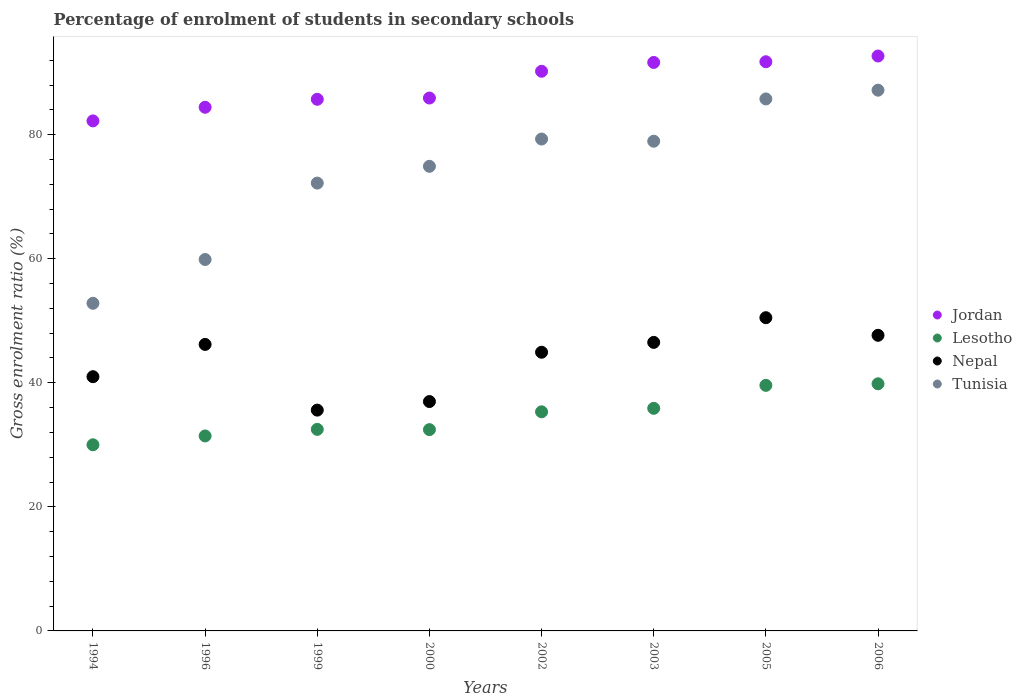Is the number of dotlines equal to the number of legend labels?
Provide a succinct answer. Yes. What is the percentage of students enrolled in secondary schools in Jordan in 2000?
Provide a short and direct response. 85.91. Across all years, what is the maximum percentage of students enrolled in secondary schools in Tunisia?
Your response must be concise. 87.17. Across all years, what is the minimum percentage of students enrolled in secondary schools in Tunisia?
Offer a very short reply. 52.82. In which year was the percentage of students enrolled in secondary schools in Jordan minimum?
Your answer should be very brief. 1994. What is the total percentage of students enrolled in secondary schools in Lesotho in the graph?
Offer a very short reply. 277.01. What is the difference between the percentage of students enrolled in secondary schools in Nepal in 1994 and that in 2000?
Make the answer very short. 4.01. What is the difference between the percentage of students enrolled in secondary schools in Nepal in 2006 and the percentage of students enrolled in secondary schools in Jordan in 1999?
Give a very brief answer. -38.04. What is the average percentage of students enrolled in secondary schools in Jordan per year?
Give a very brief answer. 88.07. In the year 2002, what is the difference between the percentage of students enrolled in secondary schools in Jordan and percentage of students enrolled in secondary schools in Tunisia?
Give a very brief answer. 10.92. What is the ratio of the percentage of students enrolled in secondary schools in Nepal in 2005 to that in 2006?
Make the answer very short. 1.06. Is the percentage of students enrolled in secondary schools in Lesotho in 1996 less than that in 2003?
Ensure brevity in your answer.  Yes. Is the difference between the percentage of students enrolled in secondary schools in Jordan in 1996 and 1999 greater than the difference between the percentage of students enrolled in secondary schools in Tunisia in 1996 and 1999?
Give a very brief answer. Yes. What is the difference between the highest and the second highest percentage of students enrolled in secondary schools in Jordan?
Offer a very short reply. 0.93. What is the difference between the highest and the lowest percentage of students enrolled in secondary schools in Lesotho?
Offer a very short reply. 9.83. Is it the case that in every year, the sum of the percentage of students enrolled in secondary schools in Jordan and percentage of students enrolled in secondary schools in Lesotho  is greater than the percentage of students enrolled in secondary schools in Tunisia?
Keep it short and to the point. Yes. Does the percentage of students enrolled in secondary schools in Jordan monotonically increase over the years?
Offer a terse response. Yes. Is the percentage of students enrolled in secondary schools in Lesotho strictly less than the percentage of students enrolled in secondary schools in Jordan over the years?
Your answer should be very brief. Yes. How many years are there in the graph?
Your answer should be compact. 8. What is the difference between two consecutive major ticks on the Y-axis?
Provide a short and direct response. 20. How many legend labels are there?
Offer a terse response. 4. How are the legend labels stacked?
Make the answer very short. Vertical. What is the title of the graph?
Your answer should be compact. Percentage of enrolment of students in secondary schools. Does "Algeria" appear as one of the legend labels in the graph?
Keep it short and to the point. No. What is the Gross enrolment ratio (%) of Jordan in 1994?
Offer a terse response. 82.22. What is the Gross enrolment ratio (%) of Lesotho in 1994?
Ensure brevity in your answer.  30.01. What is the Gross enrolment ratio (%) of Nepal in 1994?
Keep it short and to the point. 40.98. What is the Gross enrolment ratio (%) in Tunisia in 1994?
Offer a terse response. 52.82. What is the Gross enrolment ratio (%) of Jordan in 1996?
Make the answer very short. 84.42. What is the Gross enrolment ratio (%) of Lesotho in 1996?
Offer a terse response. 31.43. What is the Gross enrolment ratio (%) in Nepal in 1996?
Your answer should be very brief. 46.19. What is the Gross enrolment ratio (%) of Tunisia in 1996?
Provide a short and direct response. 59.88. What is the Gross enrolment ratio (%) of Jordan in 1999?
Make the answer very short. 85.7. What is the Gross enrolment ratio (%) in Lesotho in 1999?
Offer a very short reply. 32.49. What is the Gross enrolment ratio (%) of Nepal in 1999?
Keep it short and to the point. 35.59. What is the Gross enrolment ratio (%) of Tunisia in 1999?
Offer a terse response. 72.19. What is the Gross enrolment ratio (%) of Jordan in 2000?
Your response must be concise. 85.91. What is the Gross enrolment ratio (%) of Lesotho in 2000?
Keep it short and to the point. 32.45. What is the Gross enrolment ratio (%) in Nepal in 2000?
Make the answer very short. 36.98. What is the Gross enrolment ratio (%) of Tunisia in 2000?
Give a very brief answer. 74.9. What is the Gross enrolment ratio (%) of Jordan in 2002?
Provide a short and direct response. 90.22. What is the Gross enrolment ratio (%) of Lesotho in 2002?
Your response must be concise. 35.32. What is the Gross enrolment ratio (%) of Nepal in 2002?
Offer a terse response. 44.93. What is the Gross enrolment ratio (%) in Tunisia in 2002?
Make the answer very short. 79.3. What is the Gross enrolment ratio (%) of Jordan in 2003?
Ensure brevity in your answer.  91.64. What is the Gross enrolment ratio (%) of Lesotho in 2003?
Offer a very short reply. 35.88. What is the Gross enrolment ratio (%) of Nepal in 2003?
Ensure brevity in your answer.  46.51. What is the Gross enrolment ratio (%) of Tunisia in 2003?
Provide a succinct answer. 78.95. What is the Gross enrolment ratio (%) of Jordan in 2005?
Keep it short and to the point. 91.75. What is the Gross enrolment ratio (%) in Lesotho in 2005?
Offer a terse response. 39.59. What is the Gross enrolment ratio (%) of Nepal in 2005?
Offer a terse response. 50.5. What is the Gross enrolment ratio (%) of Tunisia in 2005?
Provide a short and direct response. 85.76. What is the Gross enrolment ratio (%) in Jordan in 2006?
Your answer should be compact. 92.68. What is the Gross enrolment ratio (%) of Lesotho in 2006?
Your response must be concise. 39.84. What is the Gross enrolment ratio (%) in Nepal in 2006?
Ensure brevity in your answer.  47.66. What is the Gross enrolment ratio (%) in Tunisia in 2006?
Your answer should be very brief. 87.17. Across all years, what is the maximum Gross enrolment ratio (%) of Jordan?
Your answer should be very brief. 92.68. Across all years, what is the maximum Gross enrolment ratio (%) in Lesotho?
Your answer should be very brief. 39.84. Across all years, what is the maximum Gross enrolment ratio (%) of Nepal?
Make the answer very short. 50.5. Across all years, what is the maximum Gross enrolment ratio (%) in Tunisia?
Your answer should be very brief. 87.17. Across all years, what is the minimum Gross enrolment ratio (%) of Jordan?
Provide a short and direct response. 82.22. Across all years, what is the minimum Gross enrolment ratio (%) in Lesotho?
Ensure brevity in your answer.  30.01. Across all years, what is the minimum Gross enrolment ratio (%) in Nepal?
Provide a short and direct response. 35.59. Across all years, what is the minimum Gross enrolment ratio (%) of Tunisia?
Make the answer very short. 52.82. What is the total Gross enrolment ratio (%) in Jordan in the graph?
Your answer should be compact. 704.54. What is the total Gross enrolment ratio (%) in Lesotho in the graph?
Keep it short and to the point. 277.01. What is the total Gross enrolment ratio (%) of Nepal in the graph?
Keep it short and to the point. 349.34. What is the total Gross enrolment ratio (%) in Tunisia in the graph?
Make the answer very short. 590.96. What is the difference between the Gross enrolment ratio (%) of Jordan in 1994 and that in 1996?
Ensure brevity in your answer.  -2.2. What is the difference between the Gross enrolment ratio (%) of Lesotho in 1994 and that in 1996?
Make the answer very short. -1.42. What is the difference between the Gross enrolment ratio (%) of Nepal in 1994 and that in 1996?
Keep it short and to the point. -5.2. What is the difference between the Gross enrolment ratio (%) of Tunisia in 1994 and that in 1996?
Your answer should be compact. -7.06. What is the difference between the Gross enrolment ratio (%) in Jordan in 1994 and that in 1999?
Keep it short and to the point. -3.48. What is the difference between the Gross enrolment ratio (%) of Lesotho in 1994 and that in 1999?
Offer a very short reply. -2.49. What is the difference between the Gross enrolment ratio (%) of Nepal in 1994 and that in 1999?
Offer a terse response. 5.39. What is the difference between the Gross enrolment ratio (%) in Tunisia in 1994 and that in 1999?
Ensure brevity in your answer.  -19.38. What is the difference between the Gross enrolment ratio (%) in Jordan in 1994 and that in 2000?
Your response must be concise. -3.69. What is the difference between the Gross enrolment ratio (%) in Lesotho in 1994 and that in 2000?
Ensure brevity in your answer.  -2.44. What is the difference between the Gross enrolment ratio (%) of Nepal in 1994 and that in 2000?
Provide a succinct answer. 4.01. What is the difference between the Gross enrolment ratio (%) in Tunisia in 1994 and that in 2000?
Make the answer very short. -22.08. What is the difference between the Gross enrolment ratio (%) of Jordan in 1994 and that in 2002?
Give a very brief answer. -8. What is the difference between the Gross enrolment ratio (%) of Lesotho in 1994 and that in 2002?
Keep it short and to the point. -5.32. What is the difference between the Gross enrolment ratio (%) of Nepal in 1994 and that in 2002?
Provide a succinct answer. -3.94. What is the difference between the Gross enrolment ratio (%) of Tunisia in 1994 and that in 2002?
Keep it short and to the point. -26.48. What is the difference between the Gross enrolment ratio (%) in Jordan in 1994 and that in 2003?
Make the answer very short. -9.42. What is the difference between the Gross enrolment ratio (%) of Lesotho in 1994 and that in 2003?
Your answer should be very brief. -5.88. What is the difference between the Gross enrolment ratio (%) of Nepal in 1994 and that in 2003?
Your answer should be very brief. -5.53. What is the difference between the Gross enrolment ratio (%) in Tunisia in 1994 and that in 2003?
Offer a very short reply. -26.13. What is the difference between the Gross enrolment ratio (%) in Jordan in 1994 and that in 2005?
Your response must be concise. -9.53. What is the difference between the Gross enrolment ratio (%) in Lesotho in 1994 and that in 2005?
Ensure brevity in your answer.  -9.58. What is the difference between the Gross enrolment ratio (%) of Nepal in 1994 and that in 2005?
Ensure brevity in your answer.  -9.51. What is the difference between the Gross enrolment ratio (%) of Tunisia in 1994 and that in 2005?
Your response must be concise. -32.94. What is the difference between the Gross enrolment ratio (%) in Jordan in 1994 and that in 2006?
Offer a terse response. -10.46. What is the difference between the Gross enrolment ratio (%) of Lesotho in 1994 and that in 2006?
Offer a very short reply. -9.83. What is the difference between the Gross enrolment ratio (%) of Nepal in 1994 and that in 2006?
Make the answer very short. -6.67. What is the difference between the Gross enrolment ratio (%) of Tunisia in 1994 and that in 2006?
Your answer should be very brief. -34.36. What is the difference between the Gross enrolment ratio (%) in Jordan in 1996 and that in 1999?
Keep it short and to the point. -1.28. What is the difference between the Gross enrolment ratio (%) of Lesotho in 1996 and that in 1999?
Ensure brevity in your answer.  -1.06. What is the difference between the Gross enrolment ratio (%) of Nepal in 1996 and that in 1999?
Your response must be concise. 10.59. What is the difference between the Gross enrolment ratio (%) in Tunisia in 1996 and that in 1999?
Give a very brief answer. -12.32. What is the difference between the Gross enrolment ratio (%) of Jordan in 1996 and that in 2000?
Your answer should be compact. -1.49. What is the difference between the Gross enrolment ratio (%) in Lesotho in 1996 and that in 2000?
Offer a very short reply. -1.02. What is the difference between the Gross enrolment ratio (%) of Nepal in 1996 and that in 2000?
Keep it short and to the point. 9.21. What is the difference between the Gross enrolment ratio (%) in Tunisia in 1996 and that in 2000?
Ensure brevity in your answer.  -15.02. What is the difference between the Gross enrolment ratio (%) of Jordan in 1996 and that in 2002?
Keep it short and to the point. -5.8. What is the difference between the Gross enrolment ratio (%) in Lesotho in 1996 and that in 2002?
Make the answer very short. -3.89. What is the difference between the Gross enrolment ratio (%) in Nepal in 1996 and that in 2002?
Offer a very short reply. 1.26. What is the difference between the Gross enrolment ratio (%) of Tunisia in 1996 and that in 2002?
Ensure brevity in your answer.  -19.42. What is the difference between the Gross enrolment ratio (%) in Jordan in 1996 and that in 2003?
Provide a succinct answer. -7.23. What is the difference between the Gross enrolment ratio (%) in Lesotho in 1996 and that in 2003?
Ensure brevity in your answer.  -4.45. What is the difference between the Gross enrolment ratio (%) in Nepal in 1996 and that in 2003?
Give a very brief answer. -0.33. What is the difference between the Gross enrolment ratio (%) in Tunisia in 1996 and that in 2003?
Your response must be concise. -19.07. What is the difference between the Gross enrolment ratio (%) of Jordan in 1996 and that in 2005?
Keep it short and to the point. -7.34. What is the difference between the Gross enrolment ratio (%) of Lesotho in 1996 and that in 2005?
Provide a succinct answer. -8.16. What is the difference between the Gross enrolment ratio (%) in Nepal in 1996 and that in 2005?
Your answer should be compact. -4.31. What is the difference between the Gross enrolment ratio (%) in Tunisia in 1996 and that in 2005?
Ensure brevity in your answer.  -25.88. What is the difference between the Gross enrolment ratio (%) in Jordan in 1996 and that in 2006?
Make the answer very short. -8.26. What is the difference between the Gross enrolment ratio (%) of Lesotho in 1996 and that in 2006?
Offer a very short reply. -8.41. What is the difference between the Gross enrolment ratio (%) of Nepal in 1996 and that in 2006?
Provide a succinct answer. -1.47. What is the difference between the Gross enrolment ratio (%) of Tunisia in 1996 and that in 2006?
Keep it short and to the point. -27.3. What is the difference between the Gross enrolment ratio (%) of Jordan in 1999 and that in 2000?
Your response must be concise. -0.21. What is the difference between the Gross enrolment ratio (%) of Lesotho in 1999 and that in 2000?
Make the answer very short. 0.04. What is the difference between the Gross enrolment ratio (%) of Nepal in 1999 and that in 2000?
Offer a terse response. -1.38. What is the difference between the Gross enrolment ratio (%) in Tunisia in 1999 and that in 2000?
Provide a succinct answer. -2.71. What is the difference between the Gross enrolment ratio (%) of Jordan in 1999 and that in 2002?
Make the answer very short. -4.52. What is the difference between the Gross enrolment ratio (%) of Lesotho in 1999 and that in 2002?
Make the answer very short. -2.83. What is the difference between the Gross enrolment ratio (%) of Nepal in 1999 and that in 2002?
Your answer should be compact. -9.33. What is the difference between the Gross enrolment ratio (%) in Tunisia in 1999 and that in 2002?
Your answer should be compact. -7.1. What is the difference between the Gross enrolment ratio (%) in Jordan in 1999 and that in 2003?
Make the answer very short. -5.94. What is the difference between the Gross enrolment ratio (%) in Lesotho in 1999 and that in 2003?
Your answer should be very brief. -3.39. What is the difference between the Gross enrolment ratio (%) of Nepal in 1999 and that in 2003?
Your answer should be very brief. -10.92. What is the difference between the Gross enrolment ratio (%) of Tunisia in 1999 and that in 2003?
Give a very brief answer. -6.75. What is the difference between the Gross enrolment ratio (%) of Jordan in 1999 and that in 2005?
Provide a succinct answer. -6.05. What is the difference between the Gross enrolment ratio (%) of Lesotho in 1999 and that in 2005?
Ensure brevity in your answer.  -7.1. What is the difference between the Gross enrolment ratio (%) in Nepal in 1999 and that in 2005?
Offer a terse response. -14.9. What is the difference between the Gross enrolment ratio (%) of Tunisia in 1999 and that in 2005?
Your answer should be compact. -13.57. What is the difference between the Gross enrolment ratio (%) of Jordan in 1999 and that in 2006?
Your response must be concise. -6.98. What is the difference between the Gross enrolment ratio (%) of Lesotho in 1999 and that in 2006?
Provide a short and direct response. -7.35. What is the difference between the Gross enrolment ratio (%) of Nepal in 1999 and that in 2006?
Give a very brief answer. -12.06. What is the difference between the Gross enrolment ratio (%) of Tunisia in 1999 and that in 2006?
Offer a very short reply. -14.98. What is the difference between the Gross enrolment ratio (%) in Jordan in 2000 and that in 2002?
Keep it short and to the point. -4.31. What is the difference between the Gross enrolment ratio (%) of Lesotho in 2000 and that in 2002?
Provide a succinct answer. -2.87. What is the difference between the Gross enrolment ratio (%) of Nepal in 2000 and that in 2002?
Provide a succinct answer. -7.95. What is the difference between the Gross enrolment ratio (%) of Tunisia in 2000 and that in 2002?
Your answer should be compact. -4.4. What is the difference between the Gross enrolment ratio (%) in Jordan in 2000 and that in 2003?
Give a very brief answer. -5.74. What is the difference between the Gross enrolment ratio (%) of Lesotho in 2000 and that in 2003?
Provide a succinct answer. -3.44. What is the difference between the Gross enrolment ratio (%) of Nepal in 2000 and that in 2003?
Give a very brief answer. -9.54. What is the difference between the Gross enrolment ratio (%) in Tunisia in 2000 and that in 2003?
Provide a succinct answer. -4.05. What is the difference between the Gross enrolment ratio (%) in Jordan in 2000 and that in 2005?
Ensure brevity in your answer.  -5.85. What is the difference between the Gross enrolment ratio (%) in Lesotho in 2000 and that in 2005?
Provide a succinct answer. -7.14. What is the difference between the Gross enrolment ratio (%) in Nepal in 2000 and that in 2005?
Keep it short and to the point. -13.52. What is the difference between the Gross enrolment ratio (%) of Tunisia in 2000 and that in 2005?
Offer a terse response. -10.86. What is the difference between the Gross enrolment ratio (%) of Jordan in 2000 and that in 2006?
Your answer should be very brief. -6.77. What is the difference between the Gross enrolment ratio (%) in Lesotho in 2000 and that in 2006?
Your answer should be very brief. -7.39. What is the difference between the Gross enrolment ratio (%) of Nepal in 2000 and that in 2006?
Offer a terse response. -10.68. What is the difference between the Gross enrolment ratio (%) of Tunisia in 2000 and that in 2006?
Your answer should be very brief. -12.28. What is the difference between the Gross enrolment ratio (%) in Jordan in 2002 and that in 2003?
Offer a terse response. -1.42. What is the difference between the Gross enrolment ratio (%) in Lesotho in 2002 and that in 2003?
Keep it short and to the point. -0.56. What is the difference between the Gross enrolment ratio (%) in Nepal in 2002 and that in 2003?
Ensure brevity in your answer.  -1.59. What is the difference between the Gross enrolment ratio (%) of Tunisia in 2002 and that in 2003?
Your answer should be compact. 0.35. What is the difference between the Gross enrolment ratio (%) of Jordan in 2002 and that in 2005?
Offer a very short reply. -1.53. What is the difference between the Gross enrolment ratio (%) in Lesotho in 2002 and that in 2005?
Ensure brevity in your answer.  -4.27. What is the difference between the Gross enrolment ratio (%) of Nepal in 2002 and that in 2005?
Provide a succinct answer. -5.57. What is the difference between the Gross enrolment ratio (%) in Tunisia in 2002 and that in 2005?
Your answer should be compact. -6.46. What is the difference between the Gross enrolment ratio (%) of Jordan in 2002 and that in 2006?
Ensure brevity in your answer.  -2.46. What is the difference between the Gross enrolment ratio (%) in Lesotho in 2002 and that in 2006?
Keep it short and to the point. -4.52. What is the difference between the Gross enrolment ratio (%) in Nepal in 2002 and that in 2006?
Ensure brevity in your answer.  -2.73. What is the difference between the Gross enrolment ratio (%) of Tunisia in 2002 and that in 2006?
Provide a succinct answer. -7.88. What is the difference between the Gross enrolment ratio (%) in Jordan in 2003 and that in 2005?
Provide a short and direct response. -0.11. What is the difference between the Gross enrolment ratio (%) in Lesotho in 2003 and that in 2005?
Keep it short and to the point. -3.7. What is the difference between the Gross enrolment ratio (%) of Nepal in 2003 and that in 2005?
Make the answer very short. -3.98. What is the difference between the Gross enrolment ratio (%) of Tunisia in 2003 and that in 2005?
Give a very brief answer. -6.81. What is the difference between the Gross enrolment ratio (%) in Jordan in 2003 and that in 2006?
Your answer should be very brief. -1.04. What is the difference between the Gross enrolment ratio (%) of Lesotho in 2003 and that in 2006?
Your response must be concise. -3.96. What is the difference between the Gross enrolment ratio (%) in Nepal in 2003 and that in 2006?
Keep it short and to the point. -1.14. What is the difference between the Gross enrolment ratio (%) in Tunisia in 2003 and that in 2006?
Give a very brief answer. -8.23. What is the difference between the Gross enrolment ratio (%) of Jordan in 2005 and that in 2006?
Offer a very short reply. -0.93. What is the difference between the Gross enrolment ratio (%) in Lesotho in 2005 and that in 2006?
Give a very brief answer. -0.25. What is the difference between the Gross enrolment ratio (%) in Nepal in 2005 and that in 2006?
Keep it short and to the point. 2.84. What is the difference between the Gross enrolment ratio (%) of Tunisia in 2005 and that in 2006?
Your response must be concise. -1.41. What is the difference between the Gross enrolment ratio (%) of Jordan in 1994 and the Gross enrolment ratio (%) of Lesotho in 1996?
Provide a succinct answer. 50.79. What is the difference between the Gross enrolment ratio (%) in Jordan in 1994 and the Gross enrolment ratio (%) in Nepal in 1996?
Your answer should be very brief. 36.03. What is the difference between the Gross enrolment ratio (%) of Jordan in 1994 and the Gross enrolment ratio (%) of Tunisia in 1996?
Offer a terse response. 22.34. What is the difference between the Gross enrolment ratio (%) of Lesotho in 1994 and the Gross enrolment ratio (%) of Nepal in 1996?
Your answer should be compact. -16.18. What is the difference between the Gross enrolment ratio (%) of Lesotho in 1994 and the Gross enrolment ratio (%) of Tunisia in 1996?
Keep it short and to the point. -29.87. What is the difference between the Gross enrolment ratio (%) of Nepal in 1994 and the Gross enrolment ratio (%) of Tunisia in 1996?
Your answer should be compact. -18.89. What is the difference between the Gross enrolment ratio (%) in Jordan in 1994 and the Gross enrolment ratio (%) in Lesotho in 1999?
Make the answer very short. 49.73. What is the difference between the Gross enrolment ratio (%) in Jordan in 1994 and the Gross enrolment ratio (%) in Nepal in 1999?
Keep it short and to the point. 46.63. What is the difference between the Gross enrolment ratio (%) of Jordan in 1994 and the Gross enrolment ratio (%) of Tunisia in 1999?
Make the answer very short. 10.03. What is the difference between the Gross enrolment ratio (%) in Lesotho in 1994 and the Gross enrolment ratio (%) in Nepal in 1999?
Your answer should be very brief. -5.59. What is the difference between the Gross enrolment ratio (%) in Lesotho in 1994 and the Gross enrolment ratio (%) in Tunisia in 1999?
Offer a terse response. -42.19. What is the difference between the Gross enrolment ratio (%) of Nepal in 1994 and the Gross enrolment ratio (%) of Tunisia in 1999?
Make the answer very short. -31.21. What is the difference between the Gross enrolment ratio (%) in Jordan in 1994 and the Gross enrolment ratio (%) in Lesotho in 2000?
Make the answer very short. 49.77. What is the difference between the Gross enrolment ratio (%) of Jordan in 1994 and the Gross enrolment ratio (%) of Nepal in 2000?
Keep it short and to the point. 45.24. What is the difference between the Gross enrolment ratio (%) in Jordan in 1994 and the Gross enrolment ratio (%) in Tunisia in 2000?
Your answer should be very brief. 7.32. What is the difference between the Gross enrolment ratio (%) of Lesotho in 1994 and the Gross enrolment ratio (%) of Nepal in 2000?
Provide a succinct answer. -6.97. What is the difference between the Gross enrolment ratio (%) in Lesotho in 1994 and the Gross enrolment ratio (%) in Tunisia in 2000?
Offer a very short reply. -44.89. What is the difference between the Gross enrolment ratio (%) in Nepal in 1994 and the Gross enrolment ratio (%) in Tunisia in 2000?
Provide a short and direct response. -33.91. What is the difference between the Gross enrolment ratio (%) in Jordan in 1994 and the Gross enrolment ratio (%) in Lesotho in 2002?
Give a very brief answer. 46.9. What is the difference between the Gross enrolment ratio (%) in Jordan in 1994 and the Gross enrolment ratio (%) in Nepal in 2002?
Ensure brevity in your answer.  37.3. What is the difference between the Gross enrolment ratio (%) in Jordan in 1994 and the Gross enrolment ratio (%) in Tunisia in 2002?
Provide a succinct answer. 2.92. What is the difference between the Gross enrolment ratio (%) in Lesotho in 1994 and the Gross enrolment ratio (%) in Nepal in 2002?
Make the answer very short. -14.92. What is the difference between the Gross enrolment ratio (%) of Lesotho in 1994 and the Gross enrolment ratio (%) of Tunisia in 2002?
Provide a succinct answer. -49.29. What is the difference between the Gross enrolment ratio (%) of Nepal in 1994 and the Gross enrolment ratio (%) of Tunisia in 2002?
Offer a very short reply. -38.31. What is the difference between the Gross enrolment ratio (%) of Jordan in 1994 and the Gross enrolment ratio (%) of Lesotho in 2003?
Keep it short and to the point. 46.34. What is the difference between the Gross enrolment ratio (%) of Jordan in 1994 and the Gross enrolment ratio (%) of Nepal in 2003?
Ensure brevity in your answer.  35.71. What is the difference between the Gross enrolment ratio (%) of Jordan in 1994 and the Gross enrolment ratio (%) of Tunisia in 2003?
Your answer should be very brief. 3.28. What is the difference between the Gross enrolment ratio (%) in Lesotho in 1994 and the Gross enrolment ratio (%) in Nepal in 2003?
Your answer should be compact. -16.51. What is the difference between the Gross enrolment ratio (%) in Lesotho in 1994 and the Gross enrolment ratio (%) in Tunisia in 2003?
Give a very brief answer. -48.94. What is the difference between the Gross enrolment ratio (%) of Nepal in 1994 and the Gross enrolment ratio (%) of Tunisia in 2003?
Your answer should be very brief. -37.96. What is the difference between the Gross enrolment ratio (%) of Jordan in 1994 and the Gross enrolment ratio (%) of Lesotho in 2005?
Offer a terse response. 42.63. What is the difference between the Gross enrolment ratio (%) of Jordan in 1994 and the Gross enrolment ratio (%) of Nepal in 2005?
Give a very brief answer. 31.73. What is the difference between the Gross enrolment ratio (%) of Jordan in 1994 and the Gross enrolment ratio (%) of Tunisia in 2005?
Your answer should be very brief. -3.54. What is the difference between the Gross enrolment ratio (%) in Lesotho in 1994 and the Gross enrolment ratio (%) in Nepal in 2005?
Provide a short and direct response. -20.49. What is the difference between the Gross enrolment ratio (%) of Lesotho in 1994 and the Gross enrolment ratio (%) of Tunisia in 2005?
Keep it short and to the point. -55.75. What is the difference between the Gross enrolment ratio (%) in Nepal in 1994 and the Gross enrolment ratio (%) in Tunisia in 2005?
Give a very brief answer. -44.77. What is the difference between the Gross enrolment ratio (%) in Jordan in 1994 and the Gross enrolment ratio (%) in Lesotho in 2006?
Keep it short and to the point. 42.38. What is the difference between the Gross enrolment ratio (%) in Jordan in 1994 and the Gross enrolment ratio (%) in Nepal in 2006?
Ensure brevity in your answer.  34.56. What is the difference between the Gross enrolment ratio (%) of Jordan in 1994 and the Gross enrolment ratio (%) of Tunisia in 2006?
Your answer should be very brief. -4.95. What is the difference between the Gross enrolment ratio (%) of Lesotho in 1994 and the Gross enrolment ratio (%) of Nepal in 2006?
Your response must be concise. -17.65. What is the difference between the Gross enrolment ratio (%) of Lesotho in 1994 and the Gross enrolment ratio (%) of Tunisia in 2006?
Your response must be concise. -57.17. What is the difference between the Gross enrolment ratio (%) in Nepal in 1994 and the Gross enrolment ratio (%) in Tunisia in 2006?
Your answer should be compact. -46.19. What is the difference between the Gross enrolment ratio (%) in Jordan in 1996 and the Gross enrolment ratio (%) in Lesotho in 1999?
Offer a very short reply. 51.92. What is the difference between the Gross enrolment ratio (%) in Jordan in 1996 and the Gross enrolment ratio (%) in Nepal in 1999?
Give a very brief answer. 48.82. What is the difference between the Gross enrolment ratio (%) in Jordan in 1996 and the Gross enrolment ratio (%) in Tunisia in 1999?
Ensure brevity in your answer.  12.22. What is the difference between the Gross enrolment ratio (%) of Lesotho in 1996 and the Gross enrolment ratio (%) of Nepal in 1999?
Make the answer very short. -4.16. What is the difference between the Gross enrolment ratio (%) in Lesotho in 1996 and the Gross enrolment ratio (%) in Tunisia in 1999?
Provide a short and direct response. -40.76. What is the difference between the Gross enrolment ratio (%) in Nepal in 1996 and the Gross enrolment ratio (%) in Tunisia in 1999?
Provide a succinct answer. -26.01. What is the difference between the Gross enrolment ratio (%) in Jordan in 1996 and the Gross enrolment ratio (%) in Lesotho in 2000?
Your answer should be very brief. 51.97. What is the difference between the Gross enrolment ratio (%) of Jordan in 1996 and the Gross enrolment ratio (%) of Nepal in 2000?
Offer a very short reply. 47.44. What is the difference between the Gross enrolment ratio (%) in Jordan in 1996 and the Gross enrolment ratio (%) in Tunisia in 2000?
Give a very brief answer. 9.52. What is the difference between the Gross enrolment ratio (%) in Lesotho in 1996 and the Gross enrolment ratio (%) in Nepal in 2000?
Make the answer very short. -5.55. What is the difference between the Gross enrolment ratio (%) of Lesotho in 1996 and the Gross enrolment ratio (%) of Tunisia in 2000?
Provide a succinct answer. -43.47. What is the difference between the Gross enrolment ratio (%) of Nepal in 1996 and the Gross enrolment ratio (%) of Tunisia in 2000?
Give a very brief answer. -28.71. What is the difference between the Gross enrolment ratio (%) of Jordan in 1996 and the Gross enrolment ratio (%) of Lesotho in 2002?
Offer a terse response. 49.09. What is the difference between the Gross enrolment ratio (%) in Jordan in 1996 and the Gross enrolment ratio (%) in Nepal in 2002?
Your answer should be very brief. 39.49. What is the difference between the Gross enrolment ratio (%) of Jordan in 1996 and the Gross enrolment ratio (%) of Tunisia in 2002?
Offer a very short reply. 5.12. What is the difference between the Gross enrolment ratio (%) in Lesotho in 1996 and the Gross enrolment ratio (%) in Nepal in 2002?
Keep it short and to the point. -13.49. What is the difference between the Gross enrolment ratio (%) of Lesotho in 1996 and the Gross enrolment ratio (%) of Tunisia in 2002?
Your answer should be compact. -47.87. What is the difference between the Gross enrolment ratio (%) in Nepal in 1996 and the Gross enrolment ratio (%) in Tunisia in 2002?
Offer a terse response. -33.11. What is the difference between the Gross enrolment ratio (%) in Jordan in 1996 and the Gross enrolment ratio (%) in Lesotho in 2003?
Give a very brief answer. 48.53. What is the difference between the Gross enrolment ratio (%) in Jordan in 1996 and the Gross enrolment ratio (%) in Nepal in 2003?
Provide a short and direct response. 37.9. What is the difference between the Gross enrolment ratio (%) of Jordan in 1996 and the Gross enrolment ratio (%) of Tunisia in 2003?
Offer a terse response. 5.47. What is the difference between the Gross enrolment ratio (%) in Lesotho in 1996 and the Gross enrolment ratio (%) in Nepal in 2003?
Give a very brief answer. -15.08. What is the difference between the Gross enrolment ratio (%) of Lesotho in 1996 and the Gross enrolment ratio (%) of Tunisia in 2003?
Offer a terse response. -47.51. What is the difference between the Gross enrolment ratio (%) of Nepal in 1996 and the Gross enrolment ratio (%) of Tunisia in 2003?
Make the answer very short. -32.76. What is the difference between the Gross enrolment ratio (%) of Jordan in 1996 and the Gross enrolment ratio (%) of Lesotho in 2005?
Offer a terse response. 44.83. What is the difference between the Gross enrolment ratio (%) of Jordan in 1996 and the Gross enrolment ratio (%) of Nepal in 2005?
Your answer should be compact. 33.92. What is the difference between the Gross enrolment ratio (%) in Jordan in 1996 and the Gross enrolment ratio (%) in Tunisia in 2005?
Keep it short and to the point. -1.34. What is the difference between the Gross enrolment ratio (%) of Lesotho in 1996 and the Gross enrolment ratio (%) of Nepal in 2005?
Make the answer very short. -19.06. What is the difference between the Gross enrolment ratio (%) in Lesotho in 1996 and the Gross enrolment ratio (%) in Tunisia in 2005?
Give a very brief answer. -54.33. What is the difference between the Gross enrolment ratio (%) in Nepal in 1996 and the Gross enrolment ratio (%) in Tunisia in 2005?
Ensure brevity in your answer.  -39.57. What is the difference between the Gross enrolment ratio (%) of Jordan in 1996 and the Gross enrolment ratio (%) of Lesotho in 2006?
Give a very brief answer. 44.58. What is the difference between the Gross enrolment ratio (%) in Jordan in 1996 and the Gross enrolment ratio (%) in Nepal in 2006?
Offer a terse response. 36.76. What is the difference between the Gross enrolment ratio (%) of Jordan in 1996 and the Gross enrolment ratio (%) of Tunisia in 2006?
Offer a very short reply. -2.76. What is the difference between the Gross enrolment ratio (%) of Lesotho in 1996 and the Gross enrolment ratio (%) of Nepal in 2006?
Offer a very short reply. -16.23. What is the difference between the Gross enrolment ratio (%) in Lesotho in 1996 and the Gross enrolment ratio (%) in Tunisia in 2006?
Give a very brief answer. -55.74. What is the difference between the Gross enrolment ratio (%) in Nepal in 1996 and the Gross enrolment ratio (%) in Tunisia in 2006?
Ensure brevity in your answer.  -40.99. What is the difference between the Gross enrolment ratio (%) of Jordan in 1999 and the Gross enrolment ratio (%) of Lesotho in 2000?
Provide a short and direct response. 53.25. What is the difference between the Gross enrolment ratio (%) of Jordan in 1999 and the Gross enrolment ratio (%) of Nepal in 2000?
Ensure brevity in your answer.  48.72. What is the difference between the Gross enrolment ratio (%) in Jordan in 1999 and the Gross enrolment ratio (%) in Tunisia in 2000?
Make the answer very short. 10.8. What is the difference between the Gross enrolment ratio (%) of Lesotho in 1999 and the Gross enrolment ratio (%) of Nepal in 2000?
Offer a terse response. -4.49. What is the difference between the Gross enrolment ratio (%) of Lesotho in 1999 and the Gross enrolment ratio (%) of Tunisia in 2000?
Offer a very short reply. -42.41. What is the difference between the Gross enrolment ratio (%) in Nepal in 1999 and the Gross enrolment ratio (%) in Tunisia in 2000?
Your response must be concise. -39.3. What is the difference between the Gross enrolment ratio (%) in Jordan in 1999 and the Gross enrolment ratio (%) in Lesotho in 2002?
Your answer should be very brief. 50.38. What is the difference between the Gross enrolment ratio (%) in Jordan in 1999 and the Gross enrolment ratio (%) in Nepal in 2002?
Offer a very short reply. 40.78. What is the difference between the Gross enrolment ratio (%) of Jordan in 1999 and the Gross enrolment ratio (%) of Tunisia in 2002?
Keep it short and to the point. 6.4. What is the difference between the Gross enrolment ratio (%) of Lesotho in 1999 and the Gross enrolment ratio (%) of Nepal in 2002?
Your answer should be very brief. -12.43. What is the difference between the Gross enrolment ratio (%) in Lesotho in 1999 and the Gross enrolment ratio (%) in Tunisia in 2002?
Ensure brevity in your answer.  -46.8. What is the difference between the Gross enrolment ratio (%) in Nepal in 1999 and the Gross enrolment ratio (%) in Tunisia in 2002?
Your answer should be very brief. -43.7. What is the difference between the Gross enrolment ratio (%) in Jordan in 1999 and the Gross enrolment ratio (%) in Lesotho in 2003?
Offer a very short reply. 49.82. What is the difference between the Gross enrolment ratio (%) of Jordan in 1999 and the Gross enrolment ratio (%) of Nepal in 2003?
Provide a short and direct response. 39.19. What is the difference between the Gross enrolment ratio (%) of Jordan in 1999 and the Gross enrolment ratio (%) of Tunisia in 2003?
Make the answer very short. 6.76. What is the difference between the Gross enrolment ratio (%) in Lesotho in 1999 and the Gross enrolment ratio (%) in Nepal in 2003?
Give a very brief answer. -14.02. What is the difference between the Gross enrolment ratio (%) of Lesotho in 1999 and the Gross enrolment ratio (%) of Tunisia in 2003?
Keep it short and to the point. -46.45. What is the difference between the Gross enrolment ratio (%) of Nepal in 1999 and the Gross enrolment ratio (%) of Tunisia in 2003?
Offer a very short reply. -43.35. What is the difference between the Gross enrolment ratio (%) of Jordan in 1999 and the Gross enrolment ratio (%) of Lesotho in 2005?
Your answer should be compact. 46.11. What is the difference between the Gross enrolment ratio (%) in Jordan in 1999 and the Gross enrolment ratio (%) in Nepal in 2005?
Your response must be concise. 35.21. What is the difference between the Gross enrolment ratio (%) in Jordan in 1999 and the Gross enrolment ratio (%) in Tunisia in 2005?
Your answer should be compact. -0.06. What is the difference between the Gross enrolment ratio (%) in Lesotho in 1999 and the Gross enrolment ratio (%) in Nepal in 2005?
Offer a terse response. -18. What is the difference between the Gross enrolment ratio (%) of Lesotho in 1999 and the Gross enrolment ratio (%) of Tunisia in 2005?
Provide a short and direct response. -53.27. What is the difference between the Gross enrolment ratio (%) of Nepal in 1999 and the Gross enrolment ratio (%) of Tunisia in 2005?
Your answer should be very brief. -50.16. What is the difference between the Gross enrolment ratio (%) in Jordan in 1999 and the Gross enrolment ratio (%) in Lesotho in 2006?
Make the answer very short. 45.86. What is the difference between the Gross enrolment ratio (%) of Jordan in 1999 and the Gross enrolment ratio (%) of Nepal in 2006?
Offer a terse response. 38.04. What is the difference between the Gross enrolment ratio (%) in Jordan in 1999 and the Gross enrolment ratio (%) in Tunisia in 2006?
Your answer should be very brief. -1.47. What is the difference between the Gross enrolment ratio (%) of Lesotho in 1999 and the Gross enrolment ratio (%) of Nepal in 2006?
Keep it short and to the point. -15.16. What is the difference between the Gross enrolment ratio (%) of Lesotho in 1999 and the Gross enrolment ratio (%) of Tunisia in 2006?
Your answer should be very brief. -54.68. What is the difference between the Gross enrolment ratio (%) of Nepal in 1999 and the Gross enrolment ratio (%) of Tunisia in 2006?
Give a very brief answer. -51.58. What is the difference between the Gross enrolment ratio (%) in Jordan in 2000 and the Gross enrolment ratio (%) in Lesotho in 2002?
Offer a terse response. 50.58. What is the difference between the Gross enrolment ratio (%) of Jordan in 2000 and the Gross enrolment ratio (%) of Nepal in 2002?
Your answer should be very brief. 40.98. What is the difference between the Gross enrolment ratio (%) of Jordan in 2000 and the Gross enrolment ratio (%) of Tunisia in 2002?
Keep it short and to the point. 6.61. What is the difference between the Gross enrolment ratio (%) of Lesotho in 2000 and the Gross enrolment ratio (%) of Nepal in 2002?
Your response must be concise. -12.48. What is the difference between the Gross enrolment ratio (%) of Lesotho in 2000 and the Gross enrolment ratio (%) of Tunisia in 2002?
Your answer should be compact. -46.85. What is the difference between the Gross enrolment ratio (%) of Nepal in 2000 and the Gross enrolment ratio (%) of Tunisia in 2002?
Your response must be concise. -42.32. What is the difference between the Gross enrolment ratio (%) in Jordan in 2000 and the Gross enrolment ratio (%) in Lesotho in 2003?
Keep it short and to the point. 50.02. What is the difference between the Gross enrolment ratio (%) of Jordan in 2000 and the Gross enrolment ratio (%) of Nepal in 2003?
Make the answer very short. 39.39. What is the difference between the Gross enrolment ratio (%) of Jordan in 2000 and the Gross enrolment ratio (%) of Tunisia in 2003?
Make the answer very short. 6.96. What is the difference between the Gross enrolment ratio (%) of Lesotho in 2000 and the Gross enrolment ratio (%) of Nepal in 2003?
Your response must be concise. -14.07. What is the difference between the Gross enrolment ratio (%) in Lesotho in 2000 and the Gross enrolment ratio (%) in Tunisia in 2003?
Keep it short and to the point. -46.5. What is the difference between the Gross enrolment ratio (%) in Nepal in 2000 and the Gross enrolment ratio (%) in Tunisia in 2003?
Your response must be concise. -41.97. What is the difference between the Gross enrolment ratio (%) in Jordan in 2000 and the Gross enrolment ratio (%) in Lesotho in 2005?
Make the answer very short. 46.32. What is the difference between the Gross enrolment ratio (%) in Jordan in 2000 and the Gross enrolment ratio (%) in Nepal in 2005?
Your answer should be very brief. 35.41. What is the difference between the Gross enrolment ratio (%) of Jordan in 2000 and the Gross enrolment ratio (%) of Tunisia in 2005?
Provide a succinct answer. 0.15. What is the difference between the Gross enrolment ratio (%) of Lesotho in 2000 and the Gross enrolment ratio (%) of Nepal in 2005?
Offer a very short reply. -18.05. What is the difference between the Gross enrolment ratio (%) of Lesotho in 2000 and the Gross enrolment ratio (%) of Tunisia in 2005?
Give a very brief answer. -53.31. What is the difference between the Gross enrolment ratio (%) in Nepal in 2000 and the Gross enrolment ratio (%) in Tunisia in 2005?
Make the answer very short. -48.78. What is the difference between the Gross enrolment ratio (%) of Jordan in 2000 and the Gross enrolment ratio (%) of Lesotho in 2006?
Offer a very short reply. 46.07. What is the difference between the Gross enrolment ratio (%) of Jordan in 2000 and the Gross enrolment ratio (%) of Nepal in 2006?
Give a very brief answer. 38.25. What is the difference between the Gross enrolment ratio (%) of Jordan in 2000 and the Gross enrolment ratio (%) of Tunisia in 2006?
Your response must be concise. -1.27. What is the difference between the Gross enrolment ratio (%) in Lesotho in 2000 and the Gross enrolment ratio (%) in Nepal in 2006?
Offer a very short reply. -15.21. What is the difference between the Gross enrolment ratio (%) of Lesotho in 2000 and the Gross enrolment ratio (%) of Tunisia in 2006?
Your answer should be very brief. -54.73. What is the difference between the Gross enrolment ratio (%) of Nepal in 2000 and the Gross enrolment ratio (%) of Tunisia in 2006?
Your answer should be very brief. -50.2. What is the difference between the Gross enrolment ratio (%) in Jordan in 2002 and the Gross enrolment ratio (%) in Lesotho in 2003?
Give a very brief answer. 54.34. What is the difference between the Gross enrolment ratio (%) of Jordan in 2002 and the Gross enrolment ratio (%) of Nepal in 2003?
Give a very brief answer. 43.71. What is the difference between the Gross enrolment ratio (%) of Jordan in 2002 and the Gross enrolment ratio (%) of Tunisia in 2003?
Offer a very short reply. 11.27. What is the difference between the Gross enrolment ratio (%) of Lesotho in 2002 and the Gross enrolment ratio (%) of Nepal in 2003?
Offer a very short reply. -11.19. What is the difference between the Gross enrolment ratio (%) of Lesotho in 2002 and the Gross enrolment ratio (%) of Tunisia in 2003?
Your answer should be very brief. -43.62. What is the difference between the Gross enrolment ratio (%) of Nepal in 2002 and the Gross enrolment ratio (%) of Tunisia in 2003?
Provide a short and direct response. -34.02. What is the difference between the Gross enrolment ratio (%) in Jordan in 2002 and the Gross enrolment ratio (%) in Lesotho in 2005?
Offer a very short reply. 50.63. What is the difference between the Gross enrolment ratio (%) in Jordan in 2002 and the Gross enrolment ratio (%) in Nepal in 2005?
Your answer should be compact. 39.72. What is the difference between the Gross enrolment ratio (%) of Jordan in 2002 and the Gross enrolment ratio (%) of Tunisia in 2005?
Offer a terse response. 4.46. What is the difference between the Gross enrolment ratio (%) in Lesotho in 2002 and the Gross enrolment ratio (%) in Nepal in 2005?
Offer a very short reply. -15.17. What is the difference between the Gross enrolment ratio (%) in Lesotho in 2002 and the Gross enrolment ratio (%) in Tunisia in 2005?
Your answer should be very brief. -50.44. What is the difference between the Gross enrolment ratio (%) of Nepal in 2002 and the Gross enrolment ratio (%) of Tunisia in 2005?
Your answer should be very brief. -40.83. What is the difference between the Gross enrolment ratio (%) of Jordan in 2002 and the Gross enrolment ratio (%) of Lesotho in 2006?
Your answer should be very brief. 50.38. What is the difference between the Gross enrolment ratio (%) of Jordan in 2002 and the Gross enrolment ratio (%) of Nepal in 2006?
Your answer should be very brief. 42.56. What is the difference between the Gross enrolment ratio (%) in Jordan in 2002 and the Gross enrolment ratio (%) in Tunisia in 2006?
Your response must be concise. 3.05. What is the difference between the Gross enrolment ratio (%) of Lesotho in 2002 and the Gross enrolment ratio (%) of Nepal in 2006?
Give a very brief answer. -12.33. What is the difference between the Gross enrolment ratio (%) of Lesotho in 2002 and the Gross enrolment ratio (%) of Tunisia in 2006?
Your response must be concise. -51.85. What is the difference between the Gross enrolment ratio (%) of Nepal in 2002 and the Gross enrolment ratio (%) of Tunisia in 2006?
Your response must be concise. -42.25. What is the difference between the Gross enrolment ratio (%) of Jordan in 2003 and the Gross enrolment ratio (%) of Lesotho in 2005?
Your answer should be compact. 52.06. What is the difference between the Gross enrolment ratio (%) in Jordan in 2003 and the Gross enrolment ratio (%) in Nepal in 2005?
Give a very brief answer. 41.15. What is the difference between the Gross enrolment ratio (%) in Jordan in 2003 and the Gross enrolment ratio (%) in Tunisia in 2005?
Your answer should be very brief. 5.88. What is the difference between the Gross enrolment ratio (%) in Lesotho in 2003 and the Gross enrolment ratio (%) in Nepal in 2005?
Give a very brief answer. -14.61. What is the difference between the Gross enrolment ratio (%) in Lesotho in 2003 and the Gross enrolment ratio (%) in Tunisia in 2005?
Your answer should be very brief. -49.88. What is the difference between the Gross enrolment ratio (%) of Nepal in 2003 and the Gross enrolment ratio (%) of Tunisia in 2005?
Make the answer very short. -39.25. What is the difference between the Gross enrolment ratio (%) of Jordan in 2003 and the Gross enrolment ratio (%) of Lesotho in 2006?
Provide a short and direct response. 51.81. What is the difference between the Gross enrolment ratio (%) in Jordan in 2003 and the Gross enrolment ratio (%) in Nepal in 2006?
Make the answer very short. 43.99. What is the difference between the Gross enrolment ratio (%) in Jordan in 2003 and the Gross enrolment ratio (%) in Tunisia in 2006?
Your answer should be very brief. 4.47. What is the difference between the Gross enrolment ratio (%) in Lesotho in 2003 and the Gross enrolment ratio (%) in Nepal in 2006?
Make the answer very short. -11.77. What is the difference between the Gross enrolment ratio (%) in Lesotho in 2003 and the Gross enrolment ratio (%) in Tunisia in 2006?
Your answer should be very brief. -51.29. What is the difference between the Gross enrolment ratio (%) in Nepal in 2003 and the Gross enrolment ratio (%) in Tunisia in 2006?
Your response must be concise. -40.66. What is the difference between the Gross enrolment ratio (%) in Jordan in 2005 and the Gross enrolment ratio (%) in Lesotho in 2006?
Your answer should be compact. 51.92. What is the difference between the Gross enrolment ratio (%) of Jordan in 2005 and the Gross enrolment ratio (%) of Nepal in 2006?
Give a very brief answer. 44.1. What is the difference between the Gross enrolment ratio (%) in Jordan in 2005 and the Gross enrolment ratio (%) in Tunisia in 2006?
Provide a short and direct response. 4.58. What is the difference between the Gross enrolment ratio (%) of Lesotho in 2005 and the Gross enrolment ratio (%) of Nepal in 2006?
Ensure brevity in your answer.  -8.07. What is the difference between the Gross enrolment ratio (%) in Lesotho in 2005 and the Gross enrolment ratio (%) in Tunisia in 2006?
Give a very brief answer. -47.59. What is the difference between the Gross enrolment ratio (%) in Nepal in 2005 and the Gross enrolment ratio (%) in Tunisia in 2006?
Offer a very short reply. -36.68. What is the average Gross enrolment ratio (%) in Jordan per year?
Ensure brevity in your answer.  88.07. What is the average Gross enrolment ratio (%) of Lesotho per year?
Provide a succinct answer. 34.63. What is the average Gross enrolment ratio (%) of Nepal per year?
Provide a succinct answer. 43.67. What is the average Gross enrolment ratio (%) of Tunisia per year?
Make the answer very short. 73.87. In the year 1994, what is the difference between the Gross enrolment ratio (%) of Jordan and Gross enrolment ratio (%) of Lesotho?
Offer a terse response. 52.21. In the year 1994, what is the difference between the Gross enrolment ratio (%) of Jordan and Gross enrolment ratio (%) of Nepal?
Offer a very short reply. 41.24. In the year 1994, what is the difference between the Gross enrolment ratio (%) in Jordan and Gross enrolment ratio (%) in Tunisia?
Ensure brevity in your answer.  29.4. In the year 1994, what is the difference between the Gross enrolment ratio (%) of Lesotho and Gross enrolment ratio (%) of Nepal?
Your response must be concise. -10.98. In the year 1994, what is the difference between the Gross enrolment ratio (%) of Lesotho and Gross enrolment ratio (%) of Tunisia?
Provide a short and direct response. -22.81. In the year 1994, what is the difference between the Gross enrolment ratio (%) of Nepal and Gross enrolment ratio (%) of Tunisia?
Keep it short and to the point. -11.83. In the year 1996, what is the difference between the Gross enrolment ratio (%) in Jordan and Gross enrolment ratio (%) in Lesotho?
Your answer should be very brief. 52.99. In the year 1996, what is the difference between the Gross enrolment ratio (%) of Jordan and Gross enrolment ratio (%) of Nepal?
Your answer should be compact. 38.23. In the year 1996, what is the difference between the Gross enrolment ratio (%) in Jordan and Gross enrolment ratio (%) in Tunisia?
Give a very brief answer. 24.54. In the year 1996, what is the difference between the Gross enrolment ratio (%) of Lesotho and Gross enrolment ratio (%) of Nepal?
Keep it short and to the point. -14.76. In the year 1996, what is the difference between the Gross enrolment ratio (%) in Lesotho and Gross enrolment ratio (%) in Tunisia?
Provide a succinct answer. -28.45. In the year 1996, what is the difference between the Gross enrolment ratio (%) of Nepal and Gross enrolment ratio (%) of Tunisia?
Ensure brevity in your answer.  -13.69. In the year 1999, what is the difference between the Gross enrolment ratio (%) in Jordan and Gross enrolment ratio (%) in Lesotho?
Your response must be concise. 53.21. In the year 1999, what is the difference between the Gross enrolment ratio (%) in Jordan and Gross enrolment ratio (%) in Nepal?
Give a very brief answer. 50.11. In the year 1999, what is the difference between the Gross enrolment ratio (%) in Jordan and Gross enrolment ratio (%) in Tunisia?
Your answer should be compact. 13.51. In the year 1999, what is the difference between the Gross enrolment ratio (%) of Lesotho and Gross enrolment ratio (%) of Nepal?
Offer a terse response. -3.1. In the year 1999, what is the difference between the Gross enrolment ratio (%) in Lesotho and Gross enrolment ratio (%) in Tunisia?
Your answer should be very brief. -39.7. In the year 1999, what is the difference between the Gross enrolment ratio (%) of Nepal and Gross enrolment ratio (%) of Tunisia?
Offer a very short reply. -36.6. In the year 2000, what is the difference between the Gross enrolment ratio (%) of Jordan and Gross enrolment ratio (%) of Lesotho?
Your answer should be compact. 53.46. In the year 2000, what is the difference between the Gross enrolment ratio (%) of Jordan and Gross enrolment ratio (%) of Nepal?
Your answer should be very brief. 48.93. In the year 2000, what is the difference between the Gross enrolment ratio (%) in Jordan and Gross enrolment ratio (%) in Tunisia?
Provide a short and direct response. 11.01. In the year 2000, what is the difference between the Gross enrolment ratio (%) in Lesotho and Gross enrolment ratio (%) in Nepal?
Your answer should be compact. -4.53. In the year 2000, what is the difference between the Gross enrolment ratio (%) in Lesotho and Gross enrolment ratio (%) in Tunisia?
Provide a succinct answer. -42.45. In the year 2000, what is the difference between the Gross enrolment ratio (%) of Nepal and Gross enrolment ratio (%) of Tunisia?
Provide a succinct answer. -37.92. In the year 2002, what is the difference between the Gross enrolment ratio (%) of Jordan and Gross enrolment ratio (%) of Lesotho?
Ensure brevity in your answer.  54.9. In the year 2002, what is the difference between the Gross enrolment ratio (%) in Jordan and Gross enrolment ratio (%) in Nepal?
Keep it short and to the point. 45.29. In the year 2002, what is the difference between the Gross enrolment ratio (%) in Jordan and Gross enrolment ratio (%) in Tunisia?
Provide a succinct answer. 10.92. In the year 2002, what is the difference between the Gross enrolment ratio (%) of Lesotho and Gross enrolment ratio (%) of Nepal?
Give a very brief answer. -9.6. In the year 2002, what is the difference between the Gross enrolment ratio (%) of Lesotho and Gross enrolment ratio (%) of Tunisia?
Give a very brief answer. -43.98. In the year 2002, what is the difference between the Gross enrolment ratio (%) of Nepal and Gross enrolment ratio (%) of Tunisia?
Offer a very short reply. -34.37. In the year 2003, what is the difference between the Gross enrolment ratio (%) of Jordan and Gross enrolment ratio (%) of Lesotho?
Provide a succinct answer. 55.76. In the year 2003, what is the difference between the Gross enrolment ratio (%) of Jordan and Gross enrolment ratio (%) of Nepal?
Keep it short and to the point. 45.13. In the year 2003, what is the difference between the Gross enrolment ratio (%) of Jordan and Gross enrolment ratio (%) of Tunisia?
Keep it short and to the point. 12.7. In the year 2003, what is the difference between the Gross enrolment ratio (%) of Lesotho and Gross enrolment ratio (%) of Nepal?
Make the answer very short. -10.63. In the year 2003, what is the difference between the Gross enrolment ratio (%) in Lesotho and Gross enrolment ratio (%) in Tunisia?
Ensure brevity in your answer.  -43.06. In the year 2003, what is the difference between the Gross enrolment ratio (%) in Nepal and Gross enrolment ratio (%) in Tunisia?
Offer a terse response. -32.43. In the year 2005, what is the difference between the Gross enrolment ratio (%) of Jordan and Gross enrolment ratio (%) of Lesotho?
Make the answer very short. 52.17. In the year 2005, what is the difference between the Gross enrolment ratio (%) in Jordan and Gross enrolment ratio (%) in Nepal?
Provide a short and direct response. 41.26. In the year 2005, what is the difference between the Gross enrolment ratio (%) of Jordan and Gross enrolment ratio (%) of Tunisia?
Make the answer very short. 5.99. In the year 2005, what is the difference between the Gross enrolment ratio (%) in Lesotho and Gross enrolment ratio (%) in Nepal?
Offer a terse response. -10.91. In the year 2005, what is the difference between the Gross enrolment ratio (%) of Lesotho and Gross enrolment ratio (%) of Tunisia?
Provide a short and direct response. -46.17. In the year 2005, what is the difference between the Gross enrolment ratio (%) of Nepal and Gross enrolment ratio (%) of Tunisia?
Ensure brevity in your answer.  -35.26. In the year 2006, what is the difference between the Gross enrolment ratio (%) of Jordan and Gross enrolment ratio (%) of Lesotho?
Give a very brief answer. 52.84. In the year 2006, what is the difference between the Gross enrolment ratio (%) in Jordan and Gross enrolment ratio (%) in Nepal?
Offer a terse response. 45.02. In the year 2006, what is the difference between the Gross enrolment ratio (%) of Jordan and Gross enrolment ratio (%) of Tunisia?
Provide a short and direct response. 5.51. In the year 2006, what is the difference between the Gross enrolment ratio (%) of Lesotho and Gross enrolment ratio (%) of Nepal?
Ensure brevity in your answer.  -7.82. In the year 2006, what is the difference between the Gross enrolment ratio (%) in Lesotho and Gross enrolment ratio (%) in Tunisia?
Your answer should be very brief. -47.34. In the year 2006, what is the difference between the Gross enrolment ratio (%) of Nepal and Gross enrolment ratio (%) of Tunisia?
Your answer should be very brief. -39.52. What is the ratio of the Gross enrolment ratio (%) of Jordan in 1994 to that in 1996?
Make the answer very short. 0.97. What is the ratio of the Gross enrolment ratio (%) in Lesotho in 1994 to that in 1996?
Ensure brevity in your answer.  0.95. What is the ratio of the Gross enrolment ratio (%) in Nepal in 1994 to that in 1996?
Make the answer very short. 0.89. What is the ratio of the Gross enrolment ratio (%) in Tunisia in 1994 to that in 1996?
Provide a succinct answer. 0.88. What is the ratio of the Gross enrolment ratio (%) of Jordan in 1994 to that in 1999?
Provide a short and direct response. 0.96. What is the ratio of the Gross enrolment ratio (%) of Lesotho in 1994 to that in 1999?
Offer a terse response. 0.92. What is the ratio of the Gross enrolment ratio (%) of Nepal in 1994 to that in 1999?
Make the answer very short. 1.15. What is the ratio of the Gross enrolment ratio (%) in Tunisia in 1994 to that in 1999?
Your answer should be compact. 0.73. What is the ratio of the Gross enrolment ratio (%) in Jordan in 1994 to that in 2000?
Offer a very short reply. 0.96. What is the ratio of the Gross enrolment ratio (%) of Lesotho in 1994 to that in 2000?
Give a very brief answer. 0.92. What is the ratio of the Gross enrolment ratio (%) of Nepal in 1994 to that in 2000?
Give a very brief answer. 1.11. What is the ratio of the Gross enrolment ratio (%) of Tunisia in 1994 to that in 2000?
Provide a short and direct response. 0.71. What is the ratio of the Gross enrolment ratio (%) of Jordan in 1994 to that in 2002?
Provide a succinct answer. 0.91. What is the ratio of the Gross enrolment ratio (%) in Lesotho in 1994 to that in 2002?
Your response must be concise. 0.85. What is the ratio of the Gross enrolment ratio (%) of Nepal in 1994 to that in 2002?
Keep it short and to the point. 0.91. What is the ratio of the Gross enrolment ratio (%) of Tunisia in 1994 to that in 2002?
Ensure brevity in your answer.  0.67. What is the ratio of the Gross enrolment ratio (%) in Jordan in 1994 to that in 2003?
Your response must be concise. 0.9. What is the ratio of the Gross enrolment ratio (%) of Lesotho in 1994 to that in 2003?
Your answer should be compact. 0.84. What is the ratio of the Gross enrolment ratio (%) of Nepal in 1994 to that in 2003?
Offer a terse response. 0.88. What is the ratio of the Gross enrolment ratio (%) of Tunisia in 1994 to that in 2003?
Offer a very short reply. 0.67. What is the ratio of the Gross enrolment ratio (%) of Jordan in 1994 to that in 2005?
Provide a succinct answer. 0.9. What is the ratio of the Gross enrolment ratio (%) in Lesotho in 1994 to that in 2005?
Your response must be concise. 0.76. What is the ratio of the Gross enrolment ratio (%) of Nepal in 1994 to that in 2005?
Offer a terse response. 0.81. What is the ratio of the Gross enrolment ratio (%) in Tunisia in 1994 to that in 2005?
Keep it short and to the point. 0.62. What is the ratio of the Gross enrolment ratio (%) of Jordan in 1994 to that in 2006?
Provide a succinct answer. 0.89. What is the ratio of the Gross enrolment ratio (%) in Lesotho in 1994 to that in 2006?
Offer a very short reply. 0.75. What is the ratio of the Gross enrolment ratio (%) in Nepal in 1994 to that in 2006?
Keep it short and to the point. 0.86. What is the ratio of the Gross enrolment ratio (%) in Tunisia in 1994 to that in 2006?
Your answer should be compact. 0.61. What is the ratio of the Gross enrolment ratio (%) in Jordan in 1996 to that in 1999?
Your answer should be compact. 0.98. What is the ratio of the Gross enrolment ratio (%) in Lesotho in 1996 to that in 1999?
Provide a short and direct response. 0.97. What is the ratio of the Gross enrolment ratio (%) in Nepal in 1996 to that in 1999?
Your response must be concise. 1.3. What is the ratio of the Gross enrolment ratio (%) in Tunisia in 1996 to that in 1999?
Keep it short and to the point. 0.83. What is the ratio of the Gross enrolment ratio (%) of Jordan in 1996 to that in 2000?
Your answer should be very brief. 0.98. What is the ratio of the Gross enrolment ratio (%) in Lesotho in 1996 to that in 2000?
Provide a short and direct response. 0.97. What is the ratio of the Gross enrolment ratio (%) in Nepal in 1996 to that in 2000?
Keep it short and to the point. 1.25. What is the ratio of the Gross enrolment ratio (%) of Tunisia in 1996 to that in 2000?
Give a very brief answer. 0.8. What is the ratio of the Gross enrolment ratio (%) in Jordan in 1996 to that in 2002?
Your answer should be compact. 0.94. What is the ratio of the Gross enrolment ratio (%) in Lesotho in 1996 to that in 2002?
Give a very brief answer. 0.89. What is the ratio of the Gross enrolment ratio (%) in Nepal in 1996 to that in 2002?
Make the answer very short. 1.03. What is the ratio of the Gross enrolment ratio (%) of Tunisia in 1996 to that in 2002?
Your answer should be very brief. 0.76. What is the ratio of the Gross enrolment ratio (%) of Jordan in 1996 to that in 2003?
Give a very brief answer. 0.92. What is the ratio of the Gross enrolment ratio (%) of Lesotho in 1996 to that in 2003?
Your answer should be very brief. 0.88. What is the ratio of the Gross enrolment ratio (%) of Nepal in 1996 to that in 2003?
Offer a very short reply. 0.99. What is the ratio of the Gross enrolment ratio (%) in Tunisia in 1996 to that in 2003?
Keep it short and to the point. 0.76. What is the ratio of the Gross enrolment ratio (%) of Lesotho in 1996 to that in 2005?
Provide a succinct answer. 0.79. What is the ratio of the Gross enrolment ratio (%) in Nepal in 1996 to that in 2005?
Your answer should be very brief. 0.91. What is the ratio of the Gross enrolment ratio (%) in Tunisia in 1996 to that in 2005?
Provide a short and direct response. 0.7. What is the ratio of the Gross enrolment ratio (%) in Jordan in 1996 to that in 2006?
Offer a very short reply. 0.91. What is the ratio of the Gross enrolment ratio (%) of Lesotho in 1996 to that in 2006?
Your answer should be compact. 0.79. What is the ratio of the Gross enrolment ratio (%) of Nepal in 1996 to that in 2006?
Provide a short and direct response. 0.97. What is the ratio of the Gross enrolment ratio (%) of Tunisia in 1996 to that in 2006?
Offer a terse response. 0.69. What is the ratio of the Gross enrolment ratio (%) of Nepal in 1999 to that in 2000?
Provide a short and direct response. 0.96. What is the ratio of the Gross enrolment ratio (%) of Tunisia in 1999 to that in 2000?
Provide a short and direct response. 0.96. What is the ratio of the Gross enrolment ratio (%) in Jordan in 1999 to that in 2002?
Offer a very short reply. 0.95. What is the ratio of the Gross enrolment ratio (%) of Lesotho in 1999 to that in 2002?
Offer a terse response. 0.92. What is the ratio of the Gross enrolment ratio (%) in Nepal in 1999 to that in 2002?
Keep it short and to the point. 0.79. What is the ratio of the Gross enrolment ratio (%) of Tunisia in 1999 to that in 2002?
Your response must be concise. 0.91. What is the ratio of the Gross enrolment ratio (%) in Jordan in 1999 to that in 2003?
Your answer should be very brief. 0.94. What is the ratio of the Gross enrolment ratio (%) of Lesotho in 1999 to that in 2003?
Your answer should be very brief. 0.91. What is the ratio of the Gross enrolment ratio (%) in Nepal in 1999 to that in 2003?
Keep it short and to the point. 0.77. What is the ratio of the Gross enrolment ratio (%) of Tunisia in 1999 to that in 2003?
Offer a very short reply. 0.91. What is the ratio of the Gross enrolment ratio (%) in Jordan in 1999 to that in 2005?
Provide a short and direct response. 0.93. What is the ratio of the Gross enrolment ratio (%) of Lesotho in 1999 to that in 2005?
Provide a succinct answer. 0.82. What is the ratio of the Gross enrolment ratio (%) of Nepal in 1999 to that in 2005?
Offer a terse response. 0.7. What is the ratio of the Gross enrolment ratio (%) of Tunisia in 1999 to that in 2005?
Offer a very short reply. 0.84. What is the ratio of the Gross enrolment ratio (%) of Jordan in 1999 to that in 2006?
Your response must be concise. 0.92. What is the ratio of the Gross enrolment ratio (%) in Lesotho in 1999 to that in 2006?
Offer a terse response. 0.82. What is the ratio of the Gross enrolment ratio (%) in Nepal in 1999 to that in 2006?
Make the answer very short. 0.75. What is the ratio of the Gross enrolment ratio (%) of Tunisia in 1999 to that in 2006?
Ensure brevity in your answer.  0.83. What is the ratio of the Gross enrolment ratio (%) in Jordan in 2000 to that in 2002?
Make the answer very short. 0.95. What is the ratio of the Gross enrolment ratio (%) of Lesotho in 2000 to that in 2002?
Give a very brief answer. 0.92. What is the ratio of the Gross enrolment ratio (%) in Nepal in 2000 to that in 2002?
Your response must be concise. 0.82. What is the ratio of the Gross enrolment ratio (%) in Tunisia in 2000 to that in 2002?
Keep it short and to the point. 0.94. What is the ratio of the Gross enrolment ratio (%) in Jordan in 2000 to that in 2003?
Keep it short and to the point. 0.94. What is the ratio of the Gross enrolment ratio (%) of Lesotho in 2000 to that in 2003?
Provide a short and direct response. 0.9. What is the ratio of the Gross enrolment ratio (%) of Nepal in 2000 to that in 2003?
Offer a terse response. 0.8. What is the ratio of the Gross enrolment ratio (%) of Tunisia in 2000 to that in 2003?
Give a very brief answer. 0.95. What is the ratio of the Gross enrolment ratio (%) in Jordan in 2000 to that in 2005?
Offer a very short reply. 0.94. What is the ratio of the Gross enrolment ratio (%) of Lesotho in 2000 to that in 2005?
Your response must be concise. 0.82. What is the ratio of the Gross enrolment ratio (%) in Nepal in 2000 to that in 2005?
Your response must be concise. 0.73. What is the ratio of the Gross enrolment ratio (%) in Tunisia in 2000 to that in 2005?
Keep it short and to the point. 0.87. What is the ratio of the Gross enrolment ratio (%) in Jordan in 2000 to that in 2006?
Provide a succinct answer. 0.93. What is the ratio of the Gross enrolment ratio (%) of Lesotho in 2000 to that in 2006?
Your response must be concise. 0.81. What is the ratio of the Gross enrolment ratio (%) in Nepal in 2000 to that in 2006?
Keep it short and to the point. 0.78. What is the ratio of the Gross enrolment ratio (%) of Tunisia in 2000 to that in 2006?
Ensure brevity in your answer.  0.86. What is the ratio of the Gross enrolment ratio (%) of Jordan in 2002 to that in 2003?
Offer a terse response. 0.98. What is the ratio of the Gross enrolment ratio (%) in Lesotho in 2002 to that in 2003?
Give a very brief answer. 0.98. What is the ratio of the Gross enrolment ratio (%) of Nepal in 2002 to that in 2003?
Provide a short and direct response. 0.97. What is the ratio of the Gross enrolment ratio (%) of Jordan in 2002 to that in 2005?
Your response must be concise. 0.98. What is the ratio of the Gross enrolment ratio (%) of Lesotho in 2002 to that in 2005?
Make the answer very short. 0.89. What is the ratio of the Gross enrolment ratio (%) in Nepal in 2002 to that in 2005?
Offer a terse response. 0.89. What is the ratio of the Gross enrolment ratio (%) of Tunisia in 2002 to that in 2005?
Give a very brief answer. 0.92. What is the ratio of the Gross enrolment ratio (%) of Jordan in 2002 to that in 2006?
Your answer should be compact. 0.97. What is the ratio of the Gross enrolment ratio (%) in Lesotho in 2002 to that in 2006?
Give a very brief answer. 0.89. What is the ratio of the Gross enrolment ratio (%) of Nepal in 2002 to that in 2006?
Offer a very short reply. 0.94. What is the ratio of the Gross enrolment ratio (%) in Tunisia in 2002 to that in 2006?
Ensure brevity in your answer.  0.91. What is the ratio of the Gross enrolment ratio (%) of Jordan in 2003 to that in 2005?
Offer a very short reply. 1. What is the ratio of the Gross enrolment ratio (%) in Lesotho in 2003 to that in 2005?
Offer a very short reply. 0.91. What is the ratio of the Gross enrolment ratio (%) of Nepal in 2003 to that in 2005?
Your answer should be compact. 0.92. What is the ratio of the Gross enrolment ratio (%) in Tunisia in 2003 to that in 2005?
Ensure brevity in your answer.  0.92. What is the ratio of the Gross enrolment ratio (%) in Lesotho in 2003 to that in 2006?
Give a very brief answer. 0.9. What is the ratio of the Gross enrolment ratio (%) of Tunisia in 2003 to that in 2006?
Ensure brevity in your answer.  0.91. What is the ratio of the Gross enrolment ratio (%) in Jordan in 2005 to that in 2006?
Offer a very short reply. 0.99. What is the ratio of the Gross enrolment ratio (%) in Nepal in 2005 to that in 2006?
Offer a very short reply. 1.06. What is the ratio of the Gross enrolment ratio (%) in Tunisia in 2005 to that in 2006?
Provide a succinct answer. 0.98. What is the difference between the highest and the second highest Gross enrolment ratio (%) of Jordan?
Your answer should be compact. 0.93. What is the difference between the highest and the second highest Gross enrolment ratio (%) of Lesotho?
Offer a very short reply. 0.25. What is the difference between the highest and the second highest Gross enrolment ratio (%) in Nepal?
Offer a terse response. 2.84. What is the difference between the highest and the second highest Gross enrolment ratio (%) in Tunisia?
Provide a succinct answer. 1.41. What is the difference between the highest and the lowest Gross enrolment ratio (%) in Jordan?
Your answer should be compact. 10.46. What is the difference between the highest and the lowest Gross enrolment ratio (%) of Lesotho?
Ensure brevity in your answer.  9.83. What is the difference between the highest and the lowest Gross enrolment ratio (%) in Nepal?
Provide a succinct answer. 14.9. What is the difference between the highest and the lowest Gross enrolment ratio (%) of Tunisia?
Provide a succinct answer. 34.36. 